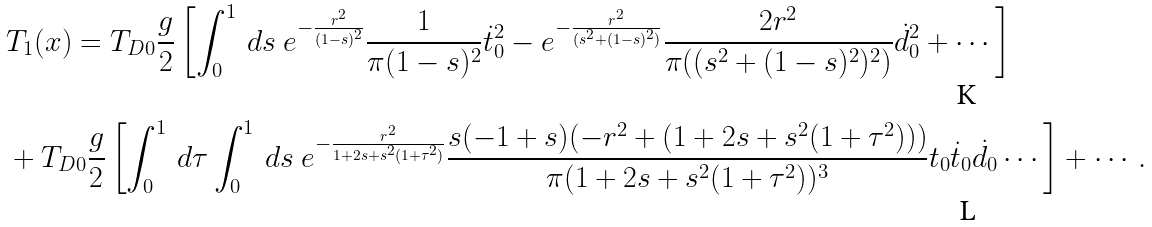<formula> <loc_0><loc_0><loc_500><loc_500>& T _ { 1 } ( x ) = T _ { D 0 } \frac { g } { 2 } \left [ \int _ { 0 } ^ { 1 } \, d s \ e ^ { - \frac { r ^ { 2 } } { ( 1 - s ) ^ { 2 } } } \frac { 1 } { \pi ( 1 - s ) ^ { 2 } } \dot { t } _ { 0 } ^ { 2 } - e ^ { - \frac { r ^ { 2 } } { ( s ^ { 2 } + ( 1 - s ) ^ { 2 } ) } } \frac { 2 r ^ { 2 } } { \pi ( ( s ^ { 2 } + ( 1 - s ) ^ { 2 } ) ^ { 2 } ) } \dot { d } _ { 0 } ^ { 2 } + \cdots \right ] \\ & + T _ { D 0 } \frac { g } { 2 } \left [ \int _ { 0 } ^ { 1 } \, d \tau \int _ { 0 } ^ { 1 } \, d s \ e ^ { - \frac { r ^ { 2 } } { 1 + 2 s + s ^ { 2 } ( 1 + \tau ^ { 2 } ) } } \frac { s ( - 1 + s ) ( - r ^ { 2 } + ( 1 + 2 s + s ^ { 2 } ( 1 + \tau ^ { 2 } ) ) ) } { \pi ( 1 + 2 s + s ^ { 2 } ( 1 + \tau ^ { 2 } ) ) ^ { 3 } } t _ { 0 } \dot { t } _ { 0 } \dot { d } _ { 0 } \cdots \right ] + \cdots .</formula> 